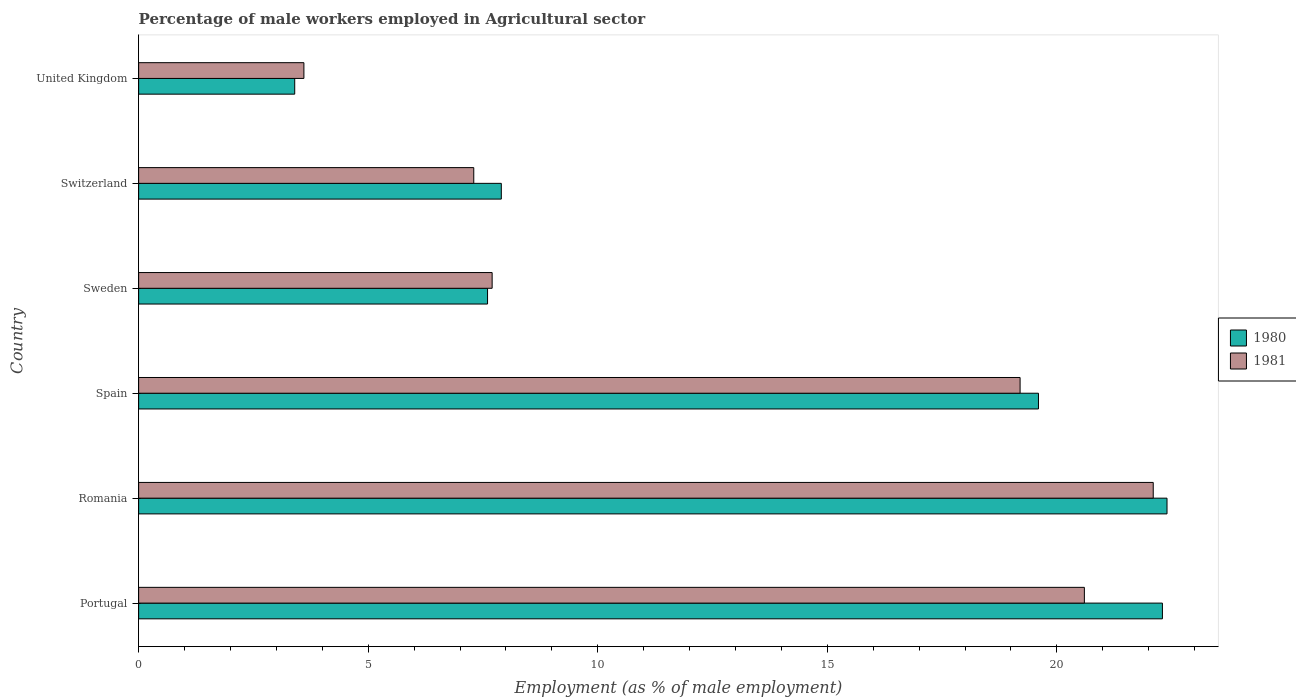Are the number of bars per tick equal to the number of legend labels?
Give a very brief answer. Yes. How many bars are there on the 4th tick from the top?
Provide a short and direct response. 2. How many bars are there on the 1st tick from the bottom?
Provide a succinct answer. 2. What is the label of the 6th group of bars from the top?
Provide a succinct answer. Portugal. What is the percentage of male workers employed in Agricultural sector in 1980 in Portugal?
Keep it short and to the point. 22.3. Across all countries, what is the maximum percentage of male workers employed in Agricultural sector in 1981?
Ensure brevity in your answer.  22.1. Across all countries, what is the minimum percentage of male workers employed in Agricultural sector in 1980?
Ensure brevity in your answer.  3.4. In which country was the percentage of male workers employed in Agricultural sector in 1981 maximum?
Make the answer very short. Romania. In which country was the percentage of male workers employed in Agricultural sector in 1981 minimum?
Your answer should be compact. United Kingdom. What is the total percentage of male workers employed in Agricultural sector in 1981 in the graph?
Ensure brevity in your answer.  80.5. What is the difference between the percentage of male workers employed in Agricultural sector in 1981 in Portugal and that in United Kingdom?
Provide a short and direct response. 17. What is the difference between the percentage of male workers employed in Agricultural sector in 1980 in Portugal and the percentage of male workers employed in Agricultural sector in 1981 in United Kingdom?
Provide a succinct answer. 18.7. What is the average percentage of male workers employed in Agricultural sector in 1981 per country?
Your answer should be compact. 13.42. What is the difference between the percentage of male workers employed in Agricultural sector in 1981 and percentage of male workers employed in Agricultural sector in 1980 in Portugal?
Your answer should be compact. -1.7. In how many countries, is the percentage of male workers employed in Agricultural sector in 1980 greater than 12 %?
Provide a short and direct response. 3. What is the ratio of the percentage of male workers employed in Agricultural sector in 1980 in Switzerland to that in United Kingdom?
Your answer should be compact. 2.32. What is the difference between the highest and the second highest percentage of male workers employed in Agricultural sector in 1981?
Provide a short and direct response. 1.5. What is the difference between the highest and the lowest percentage of male workers employed in Agricultural sector in 1981?
Your response must be concise. 18.5. In how many countries, is the percentage of male workers employed in Agricultural sector in 1981 greater than the average percentage of male workers employed in Agricultural sector in 1981 taken over all countries?
Your response must be concise. 3. What does the 1st bar from the top in Romania represents?
Your answer should be very brief. 1981. Are all the bars in the graph horizontal?
Give a very brief answer. Yes. How many countries are there in the graph?
Ensure brevity in your answer.  6. What is the difference between two consecutive major ticks on the X-axis?
Ensure brevity in your answer.  5. Does the graph contain any zero values?
Your answer should be very brief. No. Where does the legend appear in the graph?
Keep it short and to the point. Center right. How many legend labels are there?
Provide a succinct answer. 2. How are the legend labels stacked?
Provide a short and direct response. Vertical. What is the title of the graph?
Your answer should be compact. Percentage of male workers employed in Agricultural sector. Does "2007" appear as one of the legend labels in the graph?
Make the answer very short. No. What is the label or title of the X-axis?
Offer a terse response. Employment (as % of male employment). What is the Employment (as % of male employment) of 1980 in Portugal?
Ensure brevity in your answer.  22.3. What is the Employment (as % of male employment) in 1981 in Portugal?
Keep it short and to the point. 20.6. What is the Employment (as % of male employment) of 1980 in Romania?
Provide a short and direct response. 22.4. What is the Employment (as % of male employment) in 1981 in Romania?
Provide a short and direct response. 22.1. What is the Employment (as % of male employment) of 1980 in Spain?
Offer a very short reply. 19.6. What is the Employment (as % of male employment) in 1981 in Spain?
Give a very brief answer. 19.2. What is the Employment (as % of male employment) of 1980 in Sweden?
Offer a very short reply. 7.6. What is the Employment (as % of male employment) in 1981 in Sweden?
Provide a short and direct response. 7.7. What is the Employment (as % of male employment) in 1980 in Switzerland?
Keep it short and to the point. 7.9. What is the Employment (as % of male employment) of 1981 in Switzerland?
Provide a short and direct response. 7.3. What is the Employment (as % of male employment) in 1980 in United Kingdom?
Ensure brevity in your answer.  3.4. What is the Employment (as % of male employment) of 1981 in United Kingdom?
Your answer should be very brief. 3.6. Across all countries, what is the maximum Employment (as % of male employment) of 1980?
Offer a terse response. 22.4. Across all countries, what is the maximum Employment (as % of male employment) in 1981?
Keep it short and to the point. 22.1. Across all countries, what is the minimum Employment (as % of male employment) of 1980?
Your answer should be compact. 3.4. Across all countries, what is the minimum Employment (as % of male employment) in 1981?
Provide a short and direct response. 3.6. What is the total Employment (as % of male employment) in 1980 in the graph?
Make the answer very short. 83.2. What is the total Employment (as % of male employment) of 1981 in the graph?
Your answer should be compact. 80.5. What is the difference between the Employment (as % of male employment) of 1981 in Portugal and that in Romania?
Offer a very short reply. -1.5. What is the difference between the Employment (as % of male employment) in 1980 in Portugal and that in Spain?
Your response must be concise. 2.7. What is the difference between the Employment (as % of male employment) in 1981 in Portugal and that in Spain?
Offer a terse response. 1.4. What is the difference between the Employment (as % of male employment) of 1981 in Portugal and that in Sweden?
Keep it short and to the point. 12.9. What is the difference between the Employment (as % of male employment) in 1981 in Portugal and that in Switzerland?
Provide a succinct answer. 13.3. What is the difference between the Employment (as % of male employment) of 1980 in Romania and that in Spain?
Offer a terse response. 2.8. What is the difference between the Employment (as % of male employment) in 1981 in Romania and that in Spain?
Provide a short and direct response. 2.9. What is the difference between the Employment (as % of male employment) in 1980 in Romania and that in Switzerland?
Your response must be concise. 14.5. What is the difference between the Employment (as % of male employment) of 1981 in Romania and that in Switzerland?
Provide a short and direct response. 14.8. What is the difference between the Employment (as % of male employment) of 1980 in Spain and that in Sweden?
Your answer should be very brief. 12. What is the difference between the Employment (as % of male employment) of 1981 in Spain and that in Sweden?
Provide a short and direct response. 11.5. What is the difference between the Employment (as % of male employment) in 1981 in Spain and that in Switzerland?
Make the answer very short. 11.9. What is the difference between the Employment (as % of male employment) in 1981 in Spain and that in United Kingdom?
Offer a terse response. 15.6. What is the difference between the Employment (as % of male employment) of 1981 in Sweden and that in Switzerland?
Your response must be concise. 0.4. What is the difference between the Employment (as % of male employment) in 1980 in Switzerland and that in United Kingdom?
Your response must be concise. 4.5. What is the difference between the Employment (as % of male employment) of 1981 in Switzerland and that in United Kingdom?
Give a very brief answer. 3.7. What is the difference between the Employment (as % of male employment) of 1980 in Portugal and the Employment (as % of male employment) of 1981 in Spain?
Provide a succinct answer. 3.1. What is the difference between the Employment (as % of male employment) of 1980 in Portugal and the Employment (as % of male employment) of 1981 in United Kingdom?
Make the answer very short. 18.7. What is the difference between the Employment (as % of male employment) in 1980 in Romania and the Employment (as % of male employment) in 1981 in Sweden?
Your answer should be compact. 14.7. What is the difference between the Employment (as % of male employment) of 1980 in Romania and the Employment (as % of male employment) of 1981 in United Kingdom?
Offer a very short reply. 18.8. What is the difference between the Employment (as % of male employment) of 1980 in Spain and the Employment (as % of male employment) of 1981 in Switzerland?
Provide a short and direct response. 12.3. What is the difference between the Employment (as % of male employment) in 1980 in Spain and the Employment (as % of male employment) in 1981 in United Kingdom?
Your answer should be very brief. 16. What is the difference between the Employment (as % of male employment) of 1980 in Sweden and the Employment (as % of male employment) of 1981 in United Kingdom?
Provide a short and direct response. 4. What is the difference between the Employment (as % of male employment) in 1980 in Switzerland and the Employment (as % of male employment) in 1981 in United Kingdom?
Keep it short and to the point. 4.3. What is the average Employment (as % of male employment) in 1980 per country?
Offer a terse response. 13.87. What is the average Employment (as % of male employment) of 1981 per country?
Make the answer very short. 13.42. What is the difference between the Employment (as % of male employment) of 1980 and Employment (as % of male employment) of 1981 in Sweden?
Your response must be concise. -0.1. What is the difference between the Employment (as % of male employment) of 1980 and Employment (as % of male employment) of 1981 in Switzerland?
Provide a short and direct response. 0.6. What is the difference between the Employment (as % of male employment) of 1980 and Employment (as % of male employment) of 1981 in United Kingdom?
Your answer should be compact. -0.2. What is the ratio of the Employment (as % of male employment) of 1980 in Portugal to that in Romania?
Provide a short and direct response. 1. What is the ratio of the Employment (as % of male employment) of 1981 in Portugal to that in Romania?
Offer a very short reply. 0.93. What is the ratio of the Employment (as % of male employment) in 1980 in Portugal to that in Spain?
Your response must be concise. 1.14. What is the ratio of the Employment (as % of male employment) of 1981 in Portugal to that in Spain?
Ensure brevity in your answer.  1.07. What is the ratio of the Employment (as % of male employment) of 1980 in Portugal to that in Sweden?
Your answer should be compact. 2.93. What is the ratio of the Employment (as % of male employment) in 1981 in Portugal to that in Sweden?
Give a very brief answer. 2.68. What is the ratio of the Employment (as % of male employment) in 1980 in Portugal to that in Switzerland?
Your response must be concise. 2.82. What is the ratio of the Employment (as % of male employment) of 1981 in Portugal to that in Switzerland?
Your answer should be very brief. 2.82. What is the ratio of the Employment (as % of male employment) in 1980 in Portugal to that in United Kingdom?
Make the answer very short. 6.56. What is the ratio of the Employment (as % of male employment) of 1981 in Portugal to that in United Kingdom?
Give a very brief answer. 5.72. What is the ratio of the Employment (as % of male employment) in 1980 in Romania to that in Spain?
Provide a short and direct response. 1.14. What is the ratio of the Employment (as % of male employment) in 1981 in Romania to that in Spain?
Ensure brevity in your answer.  1.15. What is the ratio of the Employment (as % of male employment) in 1980 in Romania to that in Sweden?
Your answer should be very brief. 2.95. What is the ratio of the Employment (as % of male employment) in 1981 in Romania to that in Sweden?
Give a very brief answer. 2.87. What is the ratio of the Employment (as % of male employment) of 1980 in Romania to that in Switzerland?
Keep it short and to the point. 2.84. What is the ratio of the Employment (as % of male employment) of 1981 in Romania to that in Switzerland?
Ensure brevity in your answer.  3.03. What is the ratio of the Employment (as % of male employment) of 1980 in Romania to that in United Kingdom?
Offer a terse response. 6.59. What is the ratio of the Employment (as % of male employment) of 1981 in Romania to that in United Kingdom?
Your answer should be very brief. 6.14. What is the ratio of the Employment (as % of male employment) in 1980 in Spain to that in Sweden?
Give a very brief answer. 2.58. What is the ratio of the Employment (as % of male employment) of 1981 in Spain to that in Sweden?
Offer a very short reply. 2.49. What is the ratio of the Employment (as % of male employment) in 1980 in Spain to that in Switzerland?
Offer a terse response. 2.48. What is the ratio of the Employment (as % of male employment) in 1981 in Spain to that in Switzerland?
Your answer should be compact. 2.63. What is the ratio of the Employment (as % of male employment) in 1980 in Spain to that in United Kingdom?
Offer a very short reply. 5.76. What is the ratio of the Employment (as % of male employment) in 1981 in Spain to that in United Kingdom?
Provide a short and direct response. 5.33. What is the ratio of the Employment (as % of male employment) in 1980 in Sweden to that in Switzerland?
Provide a succinct answer. 0.96. What is the ratio of the Employment (as % of male employment) in 1981 in Sweden to that in Switzerland?
Keep it short and to the point. 1.05. What is the ratio of the Employment (as % of male employment) in 1980 in Sweden to that in United Kingdom?
Keep it short and to the point. 2.24. What is the ratio of the Employment (as % of male employment) of 1981 in Sweden to that in United Kingdom?
Give a very brief answer. 2.14. What is the ratio of the Employment (as % of male employment) in 1980 in Switzerland to that in United Kingdom?
Ensure brevity in your answer.  2.32. What is the ratio of the Employment (as % of male employment) of 1981 in Switzerland to that in United Kingdom?
Offer a terse response. 2.03. What is the difference between the highest and the second highest Employment (as % of male employment) of 1980?
Provide a succinct answer. 0.1. What is the difference between the highest and the second highest Employment (as % of male employment) of 1981?
Keep it short and to the point. 1.5. What is the difference between the highest and the lowest Employment (as % of male employment) of 1980?
Your answer should be compact. 19. 